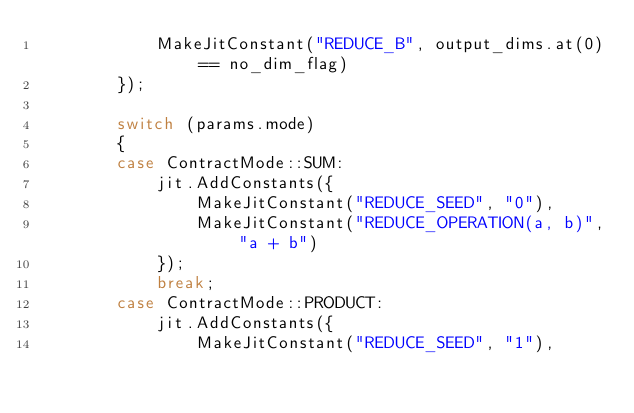<code> <loc_0><loc_0><loc_500><loc_500><_C++_>            MakeJitConstant("REDUCE_B", output_dims.at(0) == no_dim_flag)
        });

        switch (params.mode)
        {
        case ContractMode::SUM:
            jit.AddConstants({
                MakeJitConstant("REDUCE_SEED", "0"),
                MakeJitConstant("REDUCE_OPERATION(a, b)", "a + b")
            });
            break;
        case ContractMode::PRODUCT:
            jit.AddConstants({
                MakeJitConstant("REDUCE_SEED", "1"),</code> 